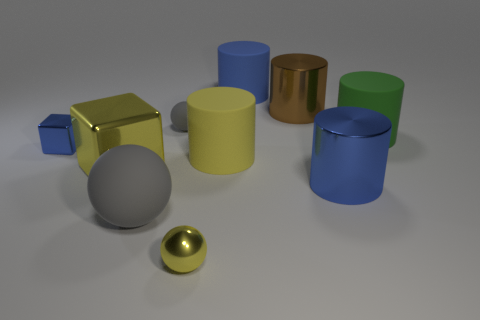Do the small rubber sphere and the metallic cylinder in front of the tiny cube have the same color?
Offer a very short reply. No. Is there a metal cylinder behind the shiny cube on the right side of the tiny blue thing in front of the small gray ball?
Offer a very short reply. Yes. The yellow thing that is made of the same material as the large sphere is what shape?
Provide a succinct answer. Cylinder. The blue rubber thing has what shape?
Offer a very short reply. Cylinder. There is a blue object behind the large green rubber object; is its shape the same as the large brown object?
Ensure brevity in your answer.  Yes. Are there more large rubber cylinders in front of the large green cylinder than large things that are behind the blue matte cylinder?
Provide a succinct answer. Yes. How many other objects are there of the same size as the yellow rubber cylinder?
Give a very brief answer. 6. Is the shape of the small gray matte thing the same as the large blue thing that is behind the tiny blue thing?
Offer a very short reply. No. What number of matte things are large objects or big balls?
Provide a succinct answer. 4. Is there a ball of the same color as the large cube?
Your response must be concise. Yes. 